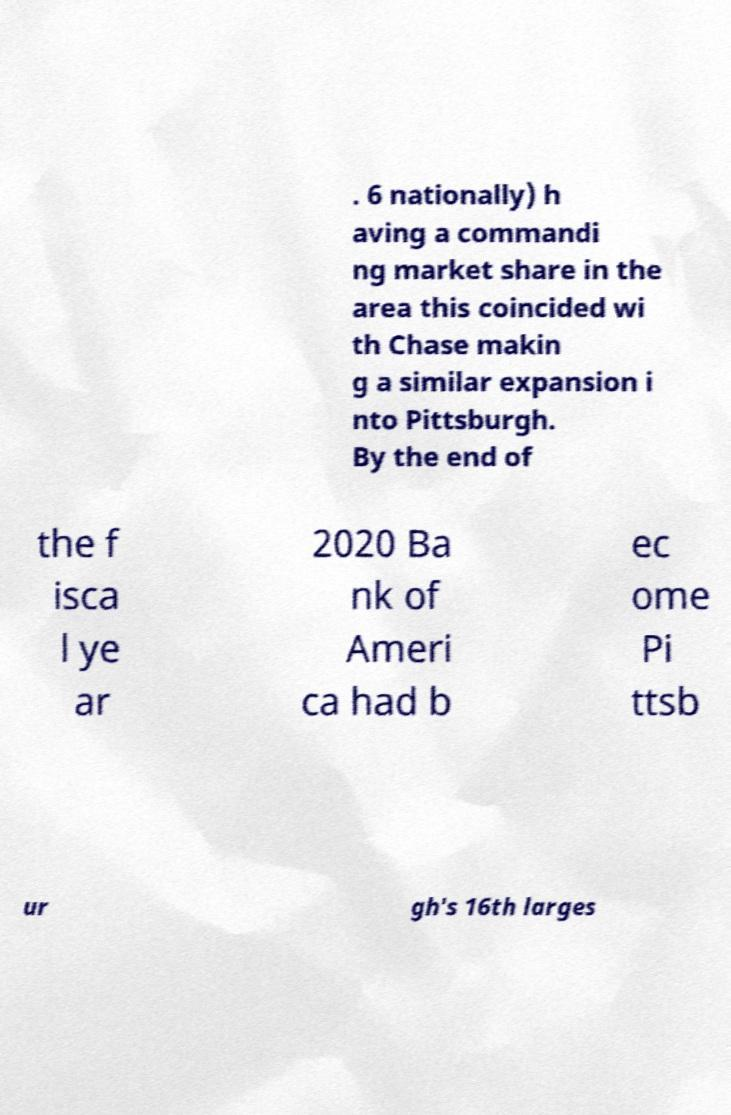Can you accurately transcribe the text from the provided image for me? . 6 nationally) h aving a commandi ng market share in the area this coincided wi th Chase makin g a similar expansion i nto Pittsburgh. By the end of the f isca l ye ar 2020 Ba nk of Ameri ca had b ec ome Pi ttsb ur gh's 16th larges 